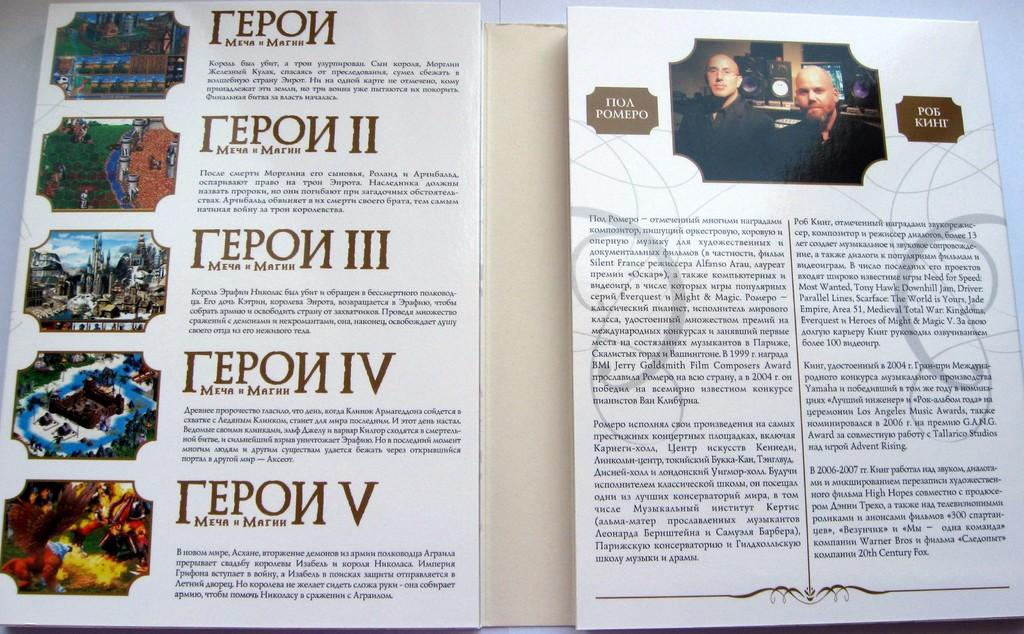What is present in the image related to reading material? There is a book in the image. What can be observed on the book's surface? The book has text and images on it. What type of belief is represented by the book in the image? The image does not convey any specific belief; it simply shows a book with text and images on it. What tax might be associated with the book in the image? There is no mention of any tax or financial aspect related to the book in the image. 